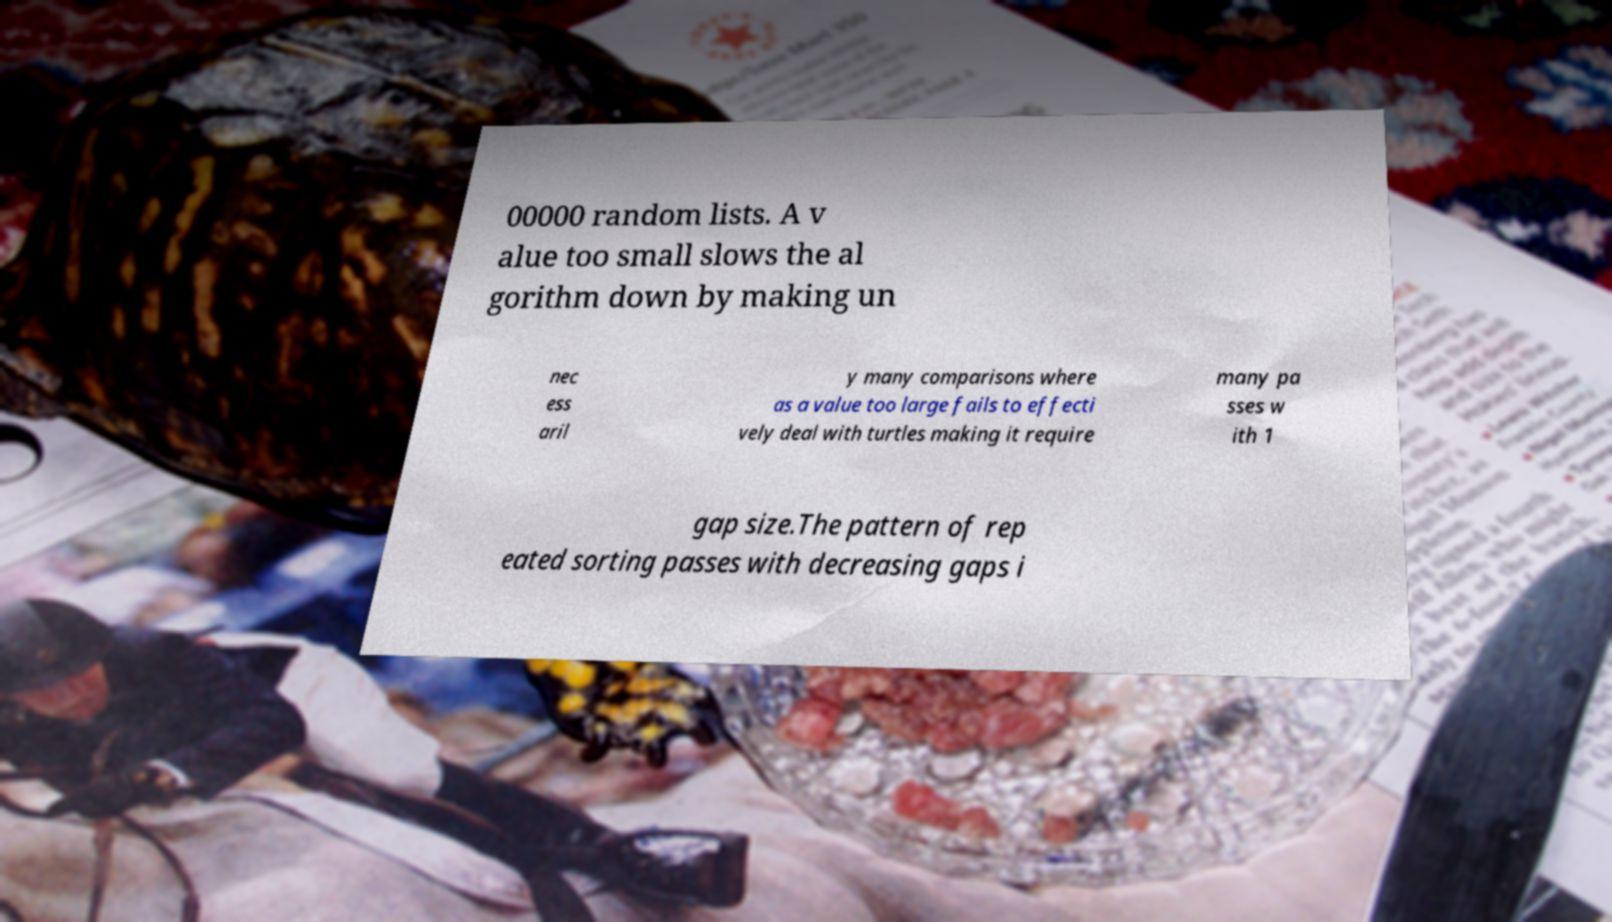Can you accurately transcribe the text from the provided image for me? 00000 random lists. A v alue too small slows the al gorithm down by making un nec ess aril y many comparisons where as a value too large fails to effecti vely deal with turtles making it require many pa sses w ith 1 gap size.The pattern of rep eated sorting passes with decreasing gaps i 